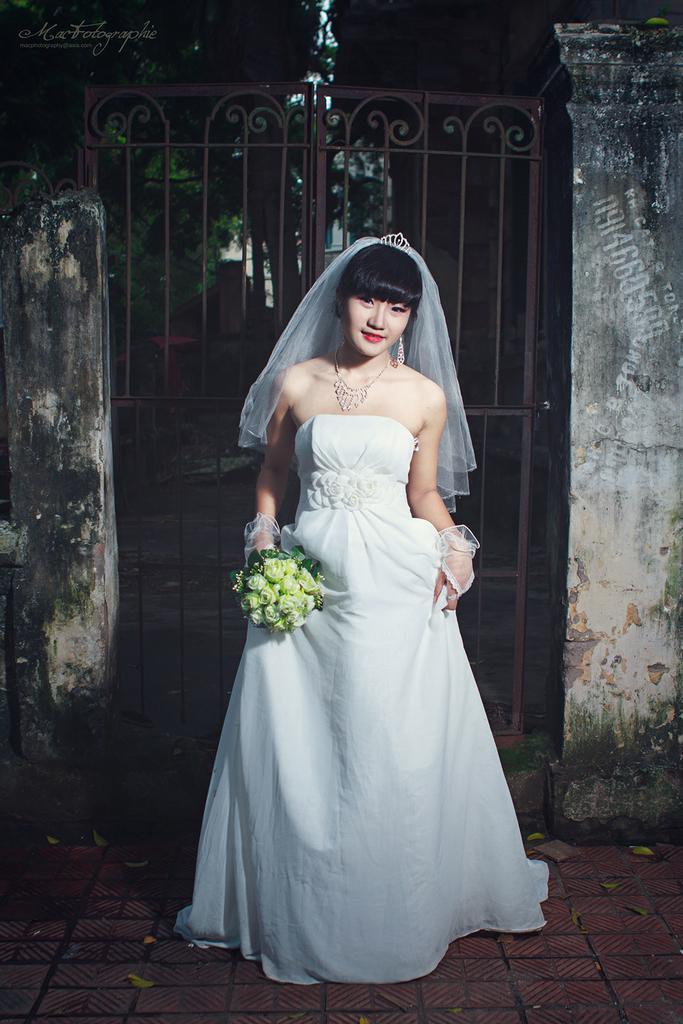Could you give a brief overview of what you see in this image? In this picture we can see a woman in the white dress. She is holding a flower bouquet. Behind the woman there is a gate, trees and walls. On the image there is a watermark. 